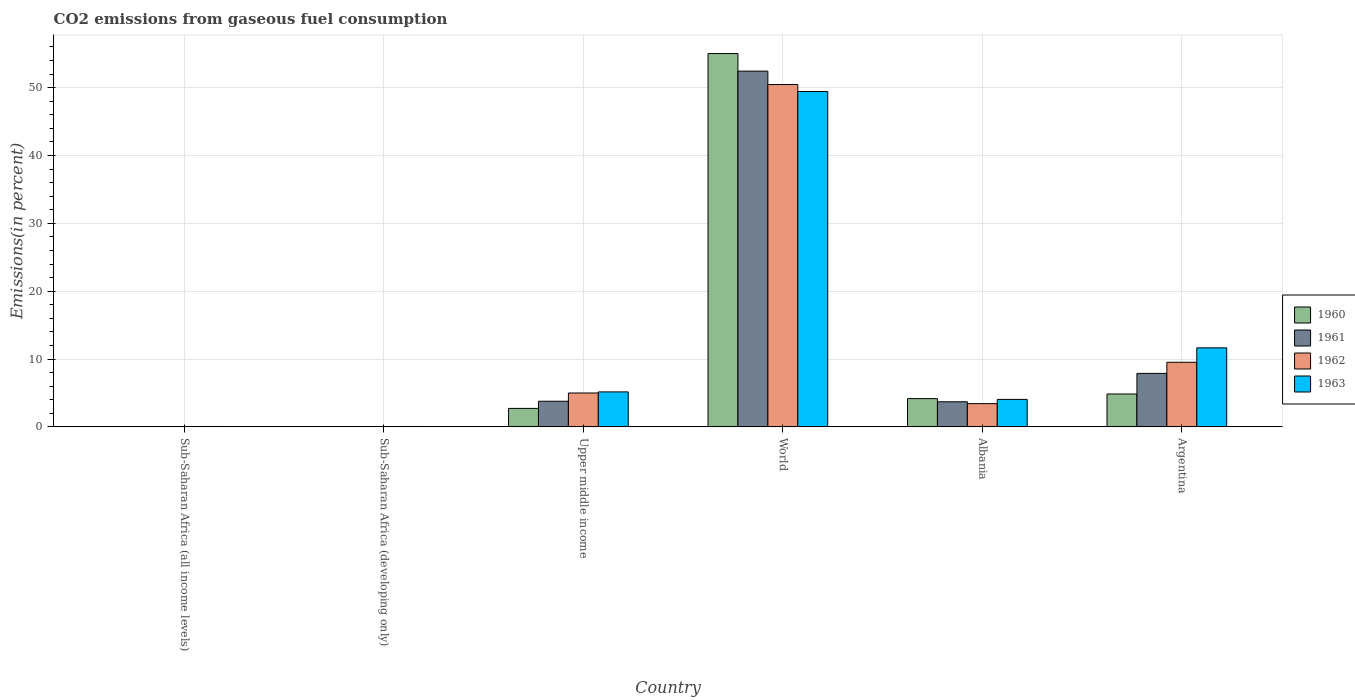How many groups of bars are there?
Offer a very short reply. 6. How many bars are there on the 2nd tick from the left?
Your response must be concise. 4. How many bars are there on the 3rd tick from the right?
Give a very brief answer. 4. What is the label of the 6th group of bars from the left?
Offer a very short reply. Argentina. What is the total CO2 emitted in 1961 in World?
Your response must be concise. 52.43. Across all countries, what is the maximum total CO2 emitted in 1963?
Offer a very short reply. 49.43. Across all countries, what is the minimum total CO2 emitted in 1962?
Make the answer very short. 0.01. In which country was the total CO2 emitted in 1962 minimum?
Keep it short and to the point. Sub-Saharan Africa (all income levels). What is the total total CO2 emitted in 1961 in the graph?
Your answer should be compact. 67.81. What is the difference between the total CO2 emitted in 1962 in Albania and that in Sub-Saharan Africa (all income levels)?
Provide a succinct answer. 3.41. What is the difference between the total CO2 emitted in 1963 in Albania and the total CO2 emitted in 1961 in World?
Provide a succinct answer. -48.38. What is the average total CO2 emitted in 1962 per country?
Give a very brief answer. 11.4. What is the difference between the total CO2 emitted of/in 1962 and total CO2 emitted of/in 1961 in World?
Your answer should be very brief. -1.98. What is the ratio of the total CO2 emitted in 1962 in Argentina to that in World?
Your answer should be compact. 0.19. Is the total CO2 emitted in 1960 in Albania less than that in Upper middle income?
Your answer should be very brief. No. What is the difference between the highest and the second highest total CO2 emitted in 1962?
Offer a very short reply. -40.94. What is the difference between the highest and the lowest total CO2 emitted in 1962?
Your response must be concise. 50.44. In how many countries, is the total CO2 emitted in 1960 greater than the average total CO2 emitted in 1960 taken over all countries?
Your answer should be compact. 1. Is the sum of the total CO2 emitted in 1961 in Sub-Saharan Africa (developing only) and World greater than the maximum total CO2 emitted in 1962 across all countries?
Keep it short and to the point. Yes. What does the 2nd bar from the left in Upper middle income represents?
Offer a terse response. 1961. Are all the bars in the graph horizontal?
Offer a very short reply. No. What is the difference between two consecutive major ticks on the Y-axis?
Ensure brevity in your answer.  10. Where does the legend appear in the graph?
Make the answer very short. Center right. How are the legend labels stacked?
Provide a succinct answer. Vertical. What is the title of the graph?
Your answer should be very brief. CO2 emissions from gaseous fuel consumption. Does "2006" appear as one of the legend labels in the graph?
Keep it short and to the point. No. What is the label or title of the Y-axis?
Give a very brief answer. Emissions(in percent). What is the Emissions(in percent) in 1960 in Sub-Saharan Africa (all income levels)?
Give a very brief answer. 0.01. What is the Emissions(in percent) in 1961 in Sub-Saharan Africa (all income levels)?
Provide a succinct answer. 0.01. What is the Emissions(in percent) of 1962 in Sub-Saharan Africa (all income levels)?
Your answer should be very brief. 0.01. What is the Emissions(in percent) of 1963 in Sub-Saharan Africa (all income levels)?
Your response must be concise. 0.06. What is the Emissions(in percent) in 1960 in Sub-Saharan Africa (developing only)?
Your answer should be compact. 0.01. What is the Emissions(in percent) of 1961 in Sub-Saharan Africa (developing only)?
Provide a succinct answer. 0.01. What is the Emissions(in percent) in 1962 in Sub-Saharan Africa (developing only)?
Provide a short and direct response. 0.01. What is the Emissions(in percent) in 1963 in Sub-Saharan Africa (developing only)?
Your answer should be compact. 0.06. What is the Emissions(in percent) of 1960 in Upper middle income?
Provide a short and direct response. 2.72. What is the Emissions(in percent) in 1961 in Upper middle income?
Your answer should be very brief. 3.78. What is the Emissions(in percent) in 1962 in Upper middle income?
Ensure brevity in your answer.  4.99. What is the Emissions(in percent) in 1963 in Upper middle income?
Your response must be concise. 5.15. What is the Emissions(in percent) of 1960 in World?
Your response must be concise. 55.02. What is the Emissions(in percent) of 1961 in World?
Make the answer very short. 52.43. What is the Emissions(in percent) in 1962 in World?
Offer a terse response. 50.46. What is the Emissions(in percent) in 1963 in World?
Make the answer very short. 49.43. What is the Emissions(in percent) of 1960 in Albania?
Provide a short and direct response. 4.17. What is the Emissions(in percent) of 1961 in Albania?
Make the answer very short. 3.7. What is the Emissions(in percent) of 1962 in Albania?
Ensure brevity in your answer.  3.42. What is the Emissions(in percent) of 1963 in Albania?
Make the answer very short. 4.05. What is the Emissions(in percent) of 1960 in Argentina?
Offer a very short reply. 4.85. What is the Emissions(in percent) of 1961 in Argentina?
Give a very brief answer. 7.88. What is the Emissions(in percent) in 1962 in Argentina?
Give a very brief answer. 9.52. What is the Emissions(in percent) of 1963 in Argentina?
Your answer should be compact. 11.65. Across all countries, what is the maximum Emissions(in percent) of 1960?
Your response must be concise. 55.02. Across all countries, what is the maximum Emissions(in percent) of 1961?
Your answer should be very brief. 52.43. Across all countries, what is the maximum Emissions(in percent) of 1962?
Offer a very short reply. 50.46. Across all countries, what is the maximum Emissions(in percent) in 1963?
Provide a succinct answer. 49.43. Across all countries, what is the minimum Emissions(in percent) of 1960?
Keep it short and to the point. 0.01. Across all countries, what is the minimum Emissions(in percent) of 1961?
Provide a succinct answer. 0.01. Across all countries, what is the minimum Emissions(in percent) in 1962?
Your response must be concise. 0.01. Across all countries, what is the minimum Emissions(in percent) of 1963?
Offer a terse response. 0.06. What is the total Emissions(in percent) of 1960 in the graph?
Provide a short and direct response. 66.78. What is the total Emissions(in percent) in 1961 in the graph?
Your answer should be very brief. 67.81. What is the total Emissions(in percent) of 1962 in the graph?
Your response must be concise. 68.42. What is the total Emissions(in percent) in 1963 in the graph?
Provide a short and direct response. 70.4. What is the difference between the Emissions(in percent) of 1960 in Sub-Saharan Africa (all income levels) and that in Sub-Saharan Africa (developing only)?
Provide a succinct answer. -0. What is the difference between the Emissions(in percent) of 1962 in Sub-Saharan Africa (all income levels) and that in Sub-Saharan Africa (developing only)?
Ensure brevity in your answer.  -0. What is the difference between the Emissions(in percent) in 1963 in Sub-Saharan Africa (all income levels) and that in Sub-Saharan Africa (developing only)?
Keep it short and to the point. -0. What is the difference between the Emissions(in percent) of 1960 in Sub-Saharan Africa (all income levels) and that in Upper middle income?
Keep it short and to the point. -2.71. What is the difference between the Emissions(in percent) of 1961 in Sub-Saharan Africa (all income levels) and that in Upper middle income?
Your answer should be compact. -3.77. What is the difference between the Emissions(in percent) in 1962 in Sub-Saharan Africa (all income levels) and that in Upper middle income?
Provide a short and direct response. -4.98. What is the difference between the Emissions(in percent) of 1963 in Sub-Saharan Africa (all income levels) and that in Upper middle income?
Keep it short and to the point. -5.1. What is the difference between the Emissions(in percent) in 1960 in Sub-Saharan Africa (all income levels) and that in World?
Give a very brief answer. -55.01. What is the difference between the Emissions(in percent) of 1961 in Sub-Saharan Africa (all income levels) and that in World?
Make the answer very short. -52.42. What is the difference between the Emissions(in percent) in 1962 in Sub-Saharan Africa (all income levels) and that in World?
Offer a terse response. -50.44. What is the difference between the Emissions(in percent) of 1963 in Sub-Saharan Africa (all income levels) and that in World?
Keep it short and to the point. -49.38. What is the difference between the Emissions(in percent) of 1960 in Sub-Saharan Africa (all income levels) and that in Albania?
Your response must be concise. -4.15. What is the difference between the Emissions(in percent) in 1961 in Sub-Saharan Africa (all income levels) and that in Albania?
Provide a short and direct response. -3.69. What is the difference between the Emissions(in percent) of 1962 in Sub-Saharan Africa (all income levels) and that in Albania?
Offer a very short reply. -3.41. What is the difference between the Emissions(in percent) of 1963 in Sub-Saharan Africa (all income levels) and that in Albania?
Make the answer very short. -3.99. What is the difference between the Emissions(in percent) in 1960 in Sub-Saharan Africa (all income levels) and that in Argentina?
Offer a very short reply. -4.83. What is the difference between the Emissions(in percent) of 1961 in Sub-Saharan Africa (all income levels) and that in Argentina?
Provide a short and direct response. -7.87. What is the difference between the Emissions(in percent) in 1962 in Sub-Saharan Africa (all income levels) and that in Argentina?
Your answer should be very brief. -9.51. What is the difference between the Emissions(in percent) of 1963 in Sub-Saharan Africa (all income levels) and that in Argentina?
Provide a short and direct response. -11.59. What is the difference between the Emissions(in percent) of 1960 in Sub-Saharan Africa (developing only) and that in Upper middle income?
Give a very brief answer. -2.71. What is the difference between the Emissions(in percent) in 1961 in Sub-Saharan Africa (developing only) and that in Upper middle income?
Your answer should be very brief. -3.77. What is the difference between the Emissions(in percent) in 1962 in Sub-Saharan Africa (developing only) and that in Upper middle income?
Your response must be concise. -4.98. What is the difference between the Emissions(in percent) of 1963 in Sub-Saharan Africa (developing only) and that in Upper middle income?
Your response must be concise. -5.1. What is the difference between the Emissions(in percent) in 1960 in Sub-Saharan Africa (developing only) and that in World?
Give a very brief answer. -55.01. What is the difference between the Emissions(in percent) of 1961 in Sub-Saharan Africa (developing only) and that in World?
Your answer should be very brief. -52.42. What is the difference between the Emissions(in percent) of 1962 in Sub-Saharan Africa (developing only) and that in World?
Your response must be concise. -50.44. What is the difference between the Emissions(in percent) of 1963 in Sub-Saharan Africa (developing only) and that in World?
Offer a very short reply. -49.38. What is the difference between the Emissions(in percent) in 1960 in Sub-Saharan Africa (developing only) and that in Albania?
Give a very brief answer. -4.15. What is the difference between the Emissions(in percent) in 1961 in Sub-Saharan Africa (developing only) and that in Albania?
Offer a terse response. -3.69. What is the difference between the Emissions(in percent) in 1962 in Sub-Saharan Africa (developing only) and that in Albania?
Give a very brief answer. -3.41. What is the difference between the Emissions(in percent) of 1963 in Sub-Saharan Africa (developing only) and that in Albania?
Your response must be concise. -3.99. What is the difference between the Emissions(in percent) in 1960 in Sub-Saharan Africa (developing only) and that in Argentina?
Offer a terse response. -4.83. What is the difference between the Emissions(in percent) in 1961 in Sub-Saharan Africa (developing only) and that in Argentina?
Keep it short and to the point. -7.87. What is the difference between the Emissions(in percent) of 1962 in Sub-Saharan Africa (developing only) and that in Argentina?
Offer a terse response. -9.51. What is the difference between the Emissions(in percent) in 1963 in Sub-Saharan Africa (developing only) and that in Argentina?
Your answer should be very brief. -11.59. What is the difference between the Emissions(in percent) in 1960 in Upper middle income and that in World?
Your answer should be compact. -52.3. What is the difference between the Emissions(in percent) in 1961 in Upper middle income and that in World?
Make the answer very short. -48.66. What is the difference between the Emissions(in percent) in 1962 in Upper middle income and that in World?
Provide a succinct answer. -45.46. What is the difference between the Emissions(in percent) of 1963 in Upper middle income and that in World?
Your answer should be compact. -44.28. What is the difference between the Emissions(in percent) of 1960 in Upper middle income and that in Albania?
Give a very brief answer. -1.44. What is the difference between the Emissions(in percent) in 1961 in Upper middle income and that in Albania?
Provide a succinct answer. 0.08. What is the difference between the Emissions(in percent) in 1962 in Upper middle income and that in Albania?
Provide a short and direct response. 1.57. What is the difference between the Emissions(in percent) in 1963 in Upper middle income and that in Albania?
Your response must be concise. 1.11. What is the difference between the Emissions(in percent) in 1960 in Upper middle income and that in Argentina?
Ensure brevity in your answer.  -2.12. What is the difference between the Emissions(in percent) in 1961 in Upper middle income and that in Argentina?
Give a very brief answer. -4.1. What is the difference between the Emissions(in percent) in 1962 in Upper middle income and that in Argentina?
Your answer should be very brief. -4.53. What is the difference between the Emissions(in percent) of 1963 in Upper middle income and that in Argentina?
Your answer should be very brief. -6.49. What is the difference between the Emissions(in percent) of 1960 in World and that in Albania?
Your answer should be compact. 50.86. What is the difference between the Emissions(in percent) in 1961 in World and that in Albania?
Offer a terse response. 48.74. What is the difference between the Emissions(in percent) of 1962 in World and that in Albania?
Ensure brevity in your answer.  47.03. What is the difference between the Emissions(in percent) in 1963 in World and that in Albania?
Your response must be concise. 45.38. What is the difference between the Emissions(in percent) of 1960 in World and that in Argentina?
Your answer should be very brief. 50.18. What is the difference between the Emissions(in percent) of 1961 in World and that in Argentina?
Keep it short and to the point. 44.55. What is the difference between the Emissions(in percent) of 1962 in World and that in Argentina?
Make the answer very short. 40.94. What is the difference between the Emissions(in percent) of 1963 in World and that in Argentina?
Your answer should be compact. 37.78. What is the difference between the Emissions(in percent) of 1960 in Albania and that in Argentina?
Provide a short and direct response. -0.68. What is the difference between the Emissions(in percent) of 1961 in Albania and that in Argentina?
Make the answer very short. -4.18. What is the difference between the Emissions(in percent) of 1962 in Albania and that in Argentina?
Ensure brevity in your answer.  -6.1. What is the difference between the Emissions(in percent) of 1963 in Albania and that in Argentina?
Your response must be concise. -7.6. What is the difference between the Emissions(in percent) in 1960 in Sub-Saharan Africa (all income levels) and the Emissions(in percent) in 1961 in Sub-Saharan Africa (developing only)?
Ensure brevity in your answer.  0. What is the difference between the Emissions(in percent) of 1960 in Sub-Saharan Africa (all income levels) and the Emissions(in percent) of 1962 in Sub-Saharan Africa (developing only)?
Provide a short and direct response. -0. What is the difference between the Emissions(in percent) of 1960 in Sub-Saharan Africa (all income levels) and the Emissions(in percent) of 1963 in Sub-Saharan Africa (developing only)?
Your answer should be very brief. -0.05. What is the difference between the Emissions(in percent) of 1961 in Sub-Saharan Africa (all income levels) and the Emissions(in percent) of 1962 in Sub-Saharan Africa (developing only)?
Ensure brevity in your answer.  -0. What is the difference between the Emissions(in percent) of 1961 in Sub-Saharan Africa (all income levels) and the Emissions(in percent) of 1963 in Sub-Saharan Africa (developing only)?
Offer a terse response. -0.05. What is the difference between the Emissions(in percent) in 1962 in Sub-Saharan Africa (all income levels) and the Emissions(in percent) in 1963 in Sub-Saharan Africa (developing only)?
Offer a terse response. -0.04. What is the difference between the Emissions(in percent) in 1960 in Sub-Saharan Africa (all income levels) and the Emissions(in percent) in 1961 in Upper middle income?
Offer a terse response. -3.77. What is the difference between the Emissions(in percent) of 1960 in Sub-Saharan Africa (all income levels) and the Emissions(in percent) of 1962 in Upper middle income?
Your response must be concise. -4.98. What is the difference between the Emissions(in percent) in 1960 in Sub-Saharan Africa (all income levels) and the Emissions(in percent) in 1963 in Upper middle income?
Offer a terse response. -5.14. What is the difference between the Emissions(in percent) in 1961 in Sub-Saharan Africa (all income levels) and the Emissions(in percent) in 1962 in Upper middle income?
Ensure brevity in your answer.  -4.98. What is the difference between the Emissions(in percent) in 1961 in Sub-Saharan Africa (all income levels) and the Emissions(in percent) in 1963 in Upper middle income?
Ensure brevity in your answer.  -5.14. What is the difference between the Emissions(in percent) of 1962 in Sub-Saharan Africa (all income levels) and the Emissions(in percent) of 1963 in Upper middle income?
Your answer should be very brief. -5.14. What is the difference between the Emissions(in percent) of 1960 in Sub-Saharan Africa (all income levels) and the Emissions(in percent) of 1961 in World?
Your answer should be very brief. -52.42. What is the difference between the Emissions(in percent) in 1960 in Sub-Saharan Africa (all income levels) and the Emissions(in percent) in 1962 in World?
Offer a very short reply. -50.44. What is the difference between the Emissions(in percent) of 1960 in Sub-Saharan Africa (all income levels) and the Emissions(in percent) of 1963 in World?
Offer a terse response. -49.42. What is the difference between the Emissions(in percent) in 1961 in Sub-Saharan Africa (all income levels) and the Emissions(in percent) in 1962 in World?
Give a very brief answer. -50.44. What is the difference between the Emissions(in percent) in 1961 in Sub-Saharan Africa (all income levels) and the Emissions(in percent) in 1963 in World?
Make the answer very short. -49.42. What is the difference between the Emissions(in percent) of 1962 in Sub-Saharan Africa (all income levels) and the Emissions(in percent) of 1963 in World?
Keep it short and to the point. -49.42. What is the difference between the Emissions(in percent) of 1960 in Sub-Saharan Africa (all income levels) and the Emissions(in percent) of 1961 in Albania?
Your answer should be very brief. -3.69. What is the difference between the Emissions(in percent) in 1960 in Sub-Saharan Africa (all income levels) and the Emissions(in percent) in 1962 in Albania?
Keep it short and to the point. -3.41. What is the difference between the Emissions(in percent) of 1960 in Sub-Saharan Africa (all income levels) and the Emissions(in percent) of 1963 in Albania?
Provide a short and direct response. -4.04. What is the difference between the Emissions(in percent) in 1961 in Sub-Saharan Africa (all income levels) and the Emissions(in percent) in 1962 in Albania?
Ensure brevity in your answer.  -3.41. What is the difference between the Emissions(in percent) in 1961 in Sub-Saharan Africa (all income levels) and the Emissions(in percent) in 1963 in Albania?
Give a very brief answer. -4.04. What is the difference between the Emissions(in percent) in 1962 in Sub-Saharan Africa (all income levels) and the Emissions(in percent) in 1963 in Albania?
Ensure brevity in your answer.  -4.03. What is the difference between the Emissions(in percent) of 1960 in Sub-Saharan Africa (all income levels) and the Emissions(in percent) of 1961 in Argentina?
Your answer should be very brief. -7.87. What is the difference between the Emissions(in percent) in 1960 in Sub-Saharan Africa (all income levels) and the Emissions(in percent) in 1962 in Argentina?
Your answer should be very brief. -9.51. What is the difference between the Emissions(in percent) of 1960 in Sub-Saharan Africa (all income levels) and the Emissions(in percent) of 1963 in Argentina?
Ensure brevity in your answer.  -11.64. What is the difference between the Emissions(in percent) in 1961 in Sub-Saharan Africa (all income levels) and the Emissions(in percent) in 1962 in Argentina?
Make the answer very short. -9.51. What is the difference between the Emissions(in percent) in 1961 in Sub-Saharan Africa (all income levels) and the Emissions(in percent) in 1963 in Argentina?
Provide a succinct answer. -11.64. What is the difference between the Emissions(in percent) in 1962 in Sub-Saharan Africa (all income levels) and the Emissions(in percent) in 1963 in Argentina?
Your answer should be compact. -11.63. What is the difference between the Emissions(in percent) of 1960 in Sub-Saharan Africa (developing only) and the Emissions(in percent) of 1961 in Upper middle income?
Give a very brief answer. -3.77. What is the difference between the Emissions(in percent) in 1960 in Sub-Saharan Africa (developing only) and the Emissions(in percent) in 1962 in Upper middle income?
Your response must be concise. -4.98. What is the difference between the Emissions(in percent) of 1960 in Sub-Saharan Africa (developing only) and the Emissions(in percent) of 1963 in Upper middle income?
Give a very brief answer. -5.14. What is the difference between the Emissions(in percent) in 1961 in Sub-Saharan Africa (developing only) and the Emissions(in percent) in 1962 in Upper middle income?
Your response must be concise. -4.98. What is the difference between the Emissions(in percent) in 1961 in Sub-Saharan Africa (developing only) and the Emissions(in percent) in 1963 in Upper middle income?
Your answer should be compact. -5.14. What is the difference between the Emissions(in percent) in 1962 in Sub-Saharan Africa (developing only) and the Emissions(in percent) in 1963 in Upper middle income?
Keep it short and to the point. -5.14. What is the difference between the Emissions(in percent) in 1960 in Sub-Saharan Africa (developing only) and the Emissions(in percent) in 1961 in World?
Ensure brevity in your answer.  -52.42. What is the difference between the Emissions(in percent) in 1960 in Sub-Saharan Africa (developing only) and the Emissions(in percent) in 1962 in World?
Offer a very short reply. -50.44. What is the difference between the Emissions(in percent) of 1960 in Sub-Saharan Africa (developing only) and the Emissions(in percent) of 1963 in World?
Make the answer very short. -49.42. What is the difference between the Emissions(in percent) in 1961 in Sub-Saharan Africa (developing only) and the Emissions(in percent) in 1962 in World?
Offer a terse response. -50.44. What is the difference between the Emissions(in percent) in 1961 in Sub-Saharan Africa (developing only) and the Emissions(in percent) in 1963 in World?
Your response must be concise. -49.42. What is the difference between the Emissions(in percent) of 1962 in Sub-Saharan Africa (developing only) and the Emissions(in percent) of 1963 in World?
Ensure brevity in your answer.  -49.42. What is the difference between the Emissions(in percent) in 1960 in Sub-Saharan Africa (developing only) and the Emissions(in percent) in 1961 in Albania?
Provide a short and direct response. -3.69. What is the difference between the Emissions(in percent) in 1960 in Sub-Saharan Africa (developing only) and the Emissions(in percent) in 1962 in Albania?
Give a very brief answer. -3.41. What is the difference between the Emissions(in percent) in 1960 in Sub-Saharan Africa (developing only) and the Emissions(in percent) in 1963 in Albania?
Ensure brevity in your answer.  -4.04. What is the difference between the Emissions(in percent) in 1961 in Sub-Saharan Africa (developing only) and the Emissions(in percent) in 1962 in Albania?
Offer a very short reply. -3.41. What is the difference between the Emissions(in percent) in 1961 in Sub-Saharan Africa (developing only) and the Emissions(in percent) in 1963 in Albania?
Provide a short and direct response. -4.04. What is the difference between the Emissions(in percent) in 1962 in Sub-Saharan Africa (developing only) and the Emissions(in percent) in 1963 in Albania?
Your answer should be compact. -4.03. What is the difference between the Emissions(in percent) of 1960 in Sub-Saharan Africa (developing only) and the Emissions(in percent) of 1961 in Argentina?
Keep it short and to the point. -7.87. What is the difference between the Emissions(in percent) of 1960 in Sub-Saharan Africa (developing only) and the Emissions(in percent) of 1962 in Argentina?
Make the answer very short. -9.51. What is the difference between the Emissions(in percent) of 1960 in Sub-Saharan Africa (developing only) and the Emissions(in percent) of 1963 in Argentina?
Provide a short and direct response. -11.64. What is the difference between the Emissions(in percent) of 1961 in Sub-Saharan Africa (developing only) and the Emissions(in percent) of 1962 in Argentina?
Make the answer very short. -9.51. What is the difference between the Emissions(in percent) in 1961 in Sub-Saharan Africa (developing only) and the Emissions(in percent) in 1963 in Argentina?
Provide a succinct answer. -11.64. What is the difference between the Emissions(in percent) of 1962 in Sub-Saharan Africa (developing only) and the Emissions(in percent) of 1963 in Argentina?
Your response must be concise. -11.63. What is the difference between the Emissions(in percent) of 1960 in Upper middle income and the Emissions(in percent) of 1961 in World?
Make the answer very short. -49.71. What is the difference between the Emissions(in percent) of 1960 in Upper middle income and the Emissions(in percent) of 1962 in World?
Offer a very short reply. -47.73. What is the difference between the Emissions(in percent) in 1960 in Upper middle income and the Emissions(in percent) in 1963 in World?
Your answer should be very brief. -46.71. What is the difference between the Emissions(in percent) of 1961 in Upper middle income and the Emissions(in percent) of 1962 in World?
Ensure brevity in your answer.  -46.68. What is the difference between the Emissions(in percent) of 1961 in Upper middle income and the Emissions(in percent) of 1963 in World?
Ensure brevity in your answer.  -45.66. What is the difference between the Emissions(in percent) of 1962 in Upper middle income and the Emissions(in percent) of 1963 in World?
Ensure brevity in your answer.  -44.44. What is the difference between the Emissions(in percent) in 1960 in Upper middle income and the Emissions(in percent) in 1961 in Albania?
Provide a succinct answer. -0.98. What is the difference between the Emissions(in percent) of 1960 in Upper middle income and the Emissions(in percent) of 1962 in Albania?
Give a very brief answer. -0.7. What is the difference between the Emissions(in percent) in 1960 in Upper middle income and the Emissions(in percent) in 1963 in Albania?
Offer a terse response. -1.33. What is the difference between the Emissions(in percent) of 1961 in Upper middle income and the Emissions(in percent) of 1962 in Albania?
Keep it short and to the point. 0.35. What is the difference between the Emissions(in percent) of 1961 in Upper middle income and the Emissions(in percent) of 1963 in Albania?
Offer a very short reply. -0.27. What is the difference between the Emissions(in percent) of 1962 in Upper middle income and the Emissions(in percent) of 1963 in Albania?
Make the answer very short. 0.94. What is the difference between the Emissions(in percent) of 1960 in Upper middle income and the Emissions(in percent) of 1961 in Argentina?
Your answer should be compact. -5.16. What is the difference between the Emissions(in percent) of 1960 in Upper middle income and the Emissions(in percent) of 1962 in Argentina?
Keep it short and to the point. -6.8. What is the difference between the Emissions(in percent) in 1960 in Upper middle income and the Emissions(in percent) in 1963 in Argentina?
Ensure brevity in your answer.  -8.93. What is the difference between the Emissions(in percent) in 1961 in Upper middle income and the Emissions(in percent) in 1962 in Argentina?
Provide a short and direct response. -5.74. What is the difference between the Emissions(in percent) in 1961 in Upper middle income and the Emissions(in percent) in 1963 in Argentina?
Your response must be concise. -7.87. What is the difference between the Emissions(in percent) of 1962 in Upper middle income and the Emissions(in percent) of 1963 in Argentina?
Your answer should be compact. -6.66. What is the difference between the Emissions(in percent) in 1960 in World and the Emissions(in percent) in 1961 in Albania?
Give a very brief answer. 51.33. What is the difference between the Emissions(in percent) of 1960 in World and the Emissions(in percent) of 1962 in Albania?
Your answer should be compact. 51.6. What is the difference between the Emissions(in percent) in 1960 in World and the Emissions(in percent) in 1963 in Albania?
Give a very brief answer. 50.98. What is the difference between the Emissions(in percent) of 1961 in World and the Emissions(in percent) of 1962 in Albania?
Keep it short and to the point. 49.01. What is the difference between the Emissions(in percent) in 1961 in World and the Emissions(in percent) in 1963 in Albania?
Give a very brief answer. 48.38. What is the difference between the Emissions(in percent) of 1962 in World and the Emissions(in percent) of 1963 in Albania?
Give a very brief answer. 46.41. What is the difference between the Emissions(in percent) in 1960 in World and the Emissions(in percent) in 1961 in Argentina?
Ensure brevity in your answer.  47.14. What is the difference between the Emissions(in percent) of 1960 in World and the Emissions(in percent) of 1962 in Argentina?
Provide a succinct answer. 45.5. What is the difference between the Emissions(in percent) of 1960 in World and the Emissions(in percent) of 1963 in Argentina?
Provide a succinct answer. 43.38. What is the difference between the Emissions(in percent) of 1961 in World and the Emissions(in percent) of 1962 in Argentina?
Your response must be concise. 42.91. What is the difference between the Emissions(in percent) in 1961 in World and the Emissions(in percent) in 1963 in Argentina?
Make the answer very short. 40.78. What is the difference between the Emissions(in percent) in 1962 in World and the Emissions(in percent) in 1963 in Argentina?
Your response must be concise. 38.81. What is the difference between the Emissions(in percent) of 1960 in Albania and the Emissions(in percent) of 1961 in Argentina?
Offer a terse response. -3.71. What is the difference between the Emissions(in percent) in 1960 in Albania and the Emissions(in percent) in 1962 in Argentina?
Make the answer very short. -5.35. What is the difference between the Emissions(in percent) in 1960 in Albania and the Emissions(in percent) in 1963 in Argentina?
Your answer should be very brief. -7.48. What is the difference between the Emissions(in percent) of 1961 in Albania and the Emissions(in percent) of 1962 in Argentina?
Offer a very short reply. -5.82. What is the difference between the Emissions(in percent) of 1961 in Albania and the Emissions(in percent) of 1963 in Argentina?
Your answer should be compact. -7.95. What is the difference between the Emissions(in percent) in 1962 in Albania and the Emissions(in percent) in 1963 in Argentina?
Your answer should be compact. -8.23. What is the average Emissions(in percent) in 1960 per country?
Your answer should be compact. 11.13. What is the average Emissions(in percent) in 1961 per country?
Provide a succinct answer. 11.3. What is the average Emissions(in percent) of 1962 per country?
Your answer should be compact. 11.4. What is the average Emissions(in percent) of 1963 per country?
Offer a terse response. 11.73. What is the difference between the Emissions(in percent) in 1960 and Emissions(in percent) in 1962 in Sub-Saharan Africa (all income levels)?
Offer a terse response. -0. What is the difference between the Emissions(in percent) in 1960 and Emissions(in percent) in 1963 in Sub-Saharan Africa (all income levels)?
Your answer should be compact. -0.05. What is the difference between the Emissions(in percent) in 1961 and Emissions(in percent) in 1962 in Sub-Saharan Africa (all income levels)?
Your response must be concise. -0. What is the difference between the Emissions(in percent) in 1961 and Emissions(in percent) in 1963 in Sub-Saharan Africa (all income levels)?
Your answer should be very brief. -0.05. What is the difference between the Emissions(in percent) in 1962 and Emissions(in percent) in 1963 in Sub-Saharan Africa (all income levels)?
Offer a very short reply. -0.04. What is the difference between the Emissions(in percent) in 1960 and Emissions(in percent) in 1962 in Sub-Saharan Africa (developing only)?
Ensure brevity in your answer.  -0. What is the difference between the Emissions(in percent) in 1960 and Emissions(in percent) in 1963 in Sub-Saharan Africa (developing only)?
Provide a succinct answer. -0.05. What is the difference between the Emissions(in percent) in 1961 and Emissions(in percent) in 1962 in Sub-Saharan Africa (developing only)?
Your response must be concise. -0. What is the difference between the Emissions(in percent) of 1961 and Emissions(in percent) of 1963 in Sub-Saharan Africa (developing only)?
Provide a succinct answer. -0.05. What is the difference between the Emissions(in percent) of 1962 and Emissions(in percent) of 1963 in Sub-Saharan Africa (developing only)?
Provide a short and direct response. -0.04. What is the difference between the Emissions(in percent) in 1960 and Emissions(in percent) in 1961 in Upper middle income?
Provide a short and direct response. -1.06. What is the difference between the Emissions(in percent) of 1960 and Emissions(in percent) of 1962 in Upper middle income?
Provide a succinct answer. -2.27. What is the difference between the Emissions(in percent) of 1960 and Emissions(in percent) of 1963 in Upper middle income?
Offer a terse response. -2.43. What is the difference between the Emissions(in percent) of 1961 and Emissions(in percent) of 1962 in Upper middle income?
Your answer should be compact. -1.22. What is the difference between the Emissions(in percent) in 1961 and Emissions(in percent) in 1963 in Upper middle income?
Offer a very short reply. -1.38. What is the difference between the Emissions(in percent) of 1962 and Emissions(in percent) of 1963 in Upper middle income?
Offer a terse response. -0.16. What is the difference between the Emissions(in percent) in 1960 and Emissions(in percent) in 1961 in World?
Keep it short and to the point. 2.59. What is the difference between the Emissions(in percent) of 1960 and Emissions(in percent) of 1962 in World?
Ensure brevity in your answer.  4.57. What is the difference between the Emissions(in percent) of 1960 and Emissions(in percent) of 1963 in World?
Your answer should be very brief. 5.59. What is the difference between the Emissions(in percent) in 1961 and Emissions(in percent) in 1962 in World?
Your answer should be very brief. 1.98. What is the difference between the Emissions(in percent) in 1961 and Emissions(in percent) in 1963 in World?
Your response must be concise. 3. What is the difference between the Emissions(in percent) of 1962 and Emissions(in percent) of 1963 in World?
Provide a succinct answer. 1.02. What is the difference between the Emissions(in percent) of 1960 and Emissions(in percent) of 1961 in Albania?
Your answer should be very brief. 0.47. What is the difference between the Emissions(in percent) of 1960 and Emissions(in percent) of 1962 in Albania?
Offer a terse response. 0.74. What is the difference between the Emissions(in percent) in 1960 and Emissions(in percent) in 1963 in Albania?
Make the answer very short. 0.12. What is the difference between the Emissions(in percent) of 1961 and Emissions(in percent) of 1962 in Albania?
Your answer should be compact. 0.28. What is the difference between the Emissions(in percent) in 1961 and Emissions(in percent) in 1963 in Albania?
Provide a succinct answer. -0.35. What is the difference between the Emissions(in percent) of 1962 and Emissions(in percent) of 1963 in Albania?
Your answer should be compact. -0.63. What is the difference between the Emissions(in percent) of 1960 and Emissions(in percent) of 1961 in Argentina?
Your response must be concise. -3.04. What is the difference between the Emissions(in percent) of 1960 and Emissions(in percent) of 1962 in Argentina?
Your answer should be very brief. -4.67. What is the difference between the Emissions(in percent) of 1960 and Emissions(in percent) of 1963 in Argentina?
Give a very brief answer. -6.8. What is the difference between the Emissions(in percent) of 1961 and Emissions(in percent) of 1962 in Argentina?
Provide a short and direct response. -1.64. What is the difference between the Emissions(in percent) in 1961 and Emissions(in percent) in 1963 in Argentina?
Offer a terse response. -3.77. What is the difference between the Emissions(in percent) in 1962 and Emissions(in percent) in 1963 in Argentina?
Keep it short and to the point. -2.13. What is the ratio of the Emissions(in percent) of 1960 in Sub-Saharan Africa (all income levels) to that in Sub-Saharan Africa (developing only)?
Provide a short and direct response. 1. What is the ratio of the Emissions(in percent) in 1961 in Sub-Saharan Africa (all income levels) to that in Sub-Saharan Africa (developing only)?
Provide a short and direct response. 1. What is the ratio of the Emissions(in percent) of 1962 in Sub-Saharan Africa (all income levels) to that in Sub-Saharan Africa (developing only)?
Offer a very short reply. 1. What is the ratio of the Emissions(in percent) of 1963 in Sub-Saharan Africa (all income levels) to that in Sub-Saharan Africa (developing only)?
Provide a succinct answer. 1. What is the ratio of the Emissions(in percent) of 1960 in Sub-Saharan Africa (all income levels) to that in Upper middle income?
Give a very brief answer. 0. What is the ratio of the Emissions(in percent) in 1961 in Sub-Saharan Africa (all income levels) to that in Upper middle income?
Provide a succinct answer. 0. What is the ratio of the Emissions(in percent) of 1962 in Sub-Saharan Africa (all income levels) to that in Upper middle income?
Your answer should be compact. 0. What is the ratio of the Emissions(in percent) of 1963 in Sub-Saharan Africa (all income levels) to that in Upper middle income?
Ensure brevity in your answer.  0.01. What is the ratio of the Emissions(in percent) of 1960 in Sub-Saharan Africa (all income levels) to that in World?
Offer a very short reply. 0. What is the ratio of the Emissions(in percent) in 1962 in Sub-Saharan Africa (all income levels) to that in World?
Offer a terse response. 0. What is the ratio of the Emissions(in percent) of 1963 in Sub-Saharan Africa (all income levels) to that in World?
Keep it short and to the point. 0. What is the ratio of the Emissions(in percent) of 1960 in Sub-Saharan Africa (all income levels) to that in Albania?
Offer a terse response. 0. What is the ratio of the Emissions(in percent) of 1961 in Sub-Saharan Africa (all income levels) to that in Albania?
Offer a terse response. 0. What is the ratio of the Emissions(in percent) in 1962 in Sub-Saharan Africa (all income levels) to that in Albania?
Offer a very short reply. 0. What is the ratio of the Emissions(in percent) of 1963 in Sub-Saharan Africa (all income levels) to that in Albania?
Keep it short and to the point. 0.01. What is the ratio of the Emissions(in percent) in 1960 in Sub-Saharan Africa (all income levels) to that in Argentina?
Give a very brief answer. 0. What is the ratio of the Emissions(in percent) of 1961 in Sub-Saharan Africa (all income levels) to that in Argentina?
Ensure brevity in your answer.  0. What is the ratio of the Emissions(in percent) in 1962 in Sub-Saharan Africa (all income levels) to that in Argentina?
Make the answer very short. 0. What is the ratio of the Emissions(in percent) in 1963 in Sub-Saharan Africa (all income levels) to that in Argentina?
Give a very brief answer. 0. What is the ratio of the Emissions(in percent) in 1960 in Sub-Saharan Africa (developing only) to that in Upper middle income?
Your answer should be compact. 0. What is the ratio of the Emissions(in percent) in 1961 in Sub-Saharan Africa (developing only) to that in Upper middle income?
Give a very brief answer. 0. What is the ratio of the Emissions(in percent) in 1962 in Sub-Saharan Africa (developing only) to that in Upper middle income?
Offer a very short reply. 0. What is the ratio of the Emissions(in percent) in 1963 in Sub-Saharan Africa (developing only) to that in Upper middle income?
Your answer should be compact. 0.01. What is the ratio of the Emissions(in percent) of 1960 in Sub-Saharan Africa (developing only) to that in World?
Your answer should be very brief. 0. What is the ratio of the Emissions(in percent) of 1961 in Sub-Saharan Africa (developing only) to that in World?
Make the answer very short. 0. What is the ratio of the Emissions(in percent) of 1963 in Sub-Saharan Africa (developing only) to that in World?
Offer a very short reply. 0. What is the ratio of the Emissions(in percent) of 1960 in Sub-Saharan Africa (developing only) to that in Albania?
Keep it short and to the point. 0. What is the ratio of the Emissions(in percent) in 1961 in Sub-Saharan Africa (developing only) to that in Albania?
Offer a terse response. 0. What is the ratio of the Emissions(in percent) of 1962 in Sub-Saharan Africa (developing only) to that in Albania?
Offer a terse response. 0. What is the ratio of the Emissions(in percent) in 1963 in Sub-Saharan Africa (developing only) to that in Albania?
Ensure brevity in your answer.  0.01. What is the ratio of the Emissions(in percent) of 1960 in Sub-Saharan Africa (developing only) to that in Argentina?
Your response must be concise. 0. What is the ratio of the Emissions(in percent) of 1961 in Sub-Saharan Africa (developing only) to that in Argentina?
Give a very brief answer. 0. What is the ratio of the Emissions(in percent) of 1962 in Sub-Saharan Africa (developing only) to that in Argentina?
Your answer should be compact. 0. What is the ratio of the Emissions(in percent) in 1963 in Sub-Saharan Africa (developing only) to that in Argentina?
Keep it short and to the point. 0. What is the ratio of the Emissions(in percent) in 1960 in Upper middle income to that in World?
Ensure brevity in your answer.  0.05. What is the ratio of the Emissions(in percent) in 1961 in Upper middle income to that in World?
Your answer should be compact. 0.07. What is the ratio of the Emissions(in percent) in 1962 in Upper middle income to that in World?
Keep it short and to the point. 0.1. What is the ratio of the Emissions(in percent) in 1963 in Upper middle income to that in World?
Ensure brevity in your answer.  0.1. What is the ratio of the Emissions(in percent) in 1960 in Upper middle income to that in Albania?
Offer a terse response. 0.65. What is the ratio of the Emissions(in percent) in 1961 in Upper middle income to that in Albania?
Make the answer very short. 1.02. What is the ratio of the Emissions(in percent) in 1962 in Upper middle income to that in Albania?
Your response must be concise. 1.46. What is the ratio of the Emissions(in percent) in 1963 in Upper middle income to that in Albania?
Make the answer very short. 1.27. What is the ratio of the Emissions(in percent) of 1960 in Upper middle income to that in Argentina?
Provide a short and direct response. 0.56. What is the ratio of the Emissions(in percent) in 1961 in Upper middle income to that in Argentina?
Offer a terse response. 0.48. What is the ratio of the Emissions(in percent) of 1962 in Upper middle income to that in Argentina?
Your answer should be very brief. 0.52. What is the ratio of the Emissions(in percent) in 1963 in Upper middle income to that in Argentina?
Provide a short and direct response. 0.44. What is the ratio of the Emissions(in percent) in 1960 in World to that in Albania?
Keep it short and to the point. 13.21. What is the ratio of the Emissions(in percent) in 1961 in World to that in Albania?
Make the answer very short. 14.18. What is the ratio of the Emissions(in percent) of 1962 in World to that in Albania?
Offer a very short reply. 14.74. What is the ratio of the Emissions(in percent) of 1963 in World to that in Albania?
Your answer should be compact. 12.21. What is the ratio of the Emissions(in percent) of 1960 in World to that in Argentina?
Make the answer very short. 11.36. What is the ratio of the Emissions(in percent) of 1961 in World to that in Argentina?
Make the answer very short. 6.65. What is the ratio of the Emissions(in percent) in 1962 in World to that in Argentina?
Offer a terse response. 5.3. What is the ratio of the Emissions(in percent) in 1963 in World to that in Argentina?
Your answer should be compact. 4.24. What is the ratio of the Emissions(in percent) of 1960 in Albania to that in Argentina?
Your answer should be very brief. 0.86. What is the ratio of the Emissions(in percent) of 1961 in Albania to that in Argentina?
Offer a very short reply. 0.47. What is the ratio of the Emissions(in percent) of 1962 in Albania to that in Argentina?
Offer a terse response. 0.36. What is the ratio of the Emissions(in percent) in 1963 in Albania to that in Argentina?
Give a very brief answer. 0.35. What is the difference between the highest and the second highest Emissions(in percent) of 1960?
Your answer should be very brief. 50.18. What is the difference between the highest and the second highest Emissions(in percent) of 1961?
Offer a terse response. 44.55. What is the difference between the highest and the second highest Emissions(in percent) in 1962?
Make the answer very short. 40.94. What is the difference between the highest and the second highest Emissions(in percent) in 1963?
Offer a very short reply. 37.78. What is the difference between the highest and the lowest Emissions(in percent) of 1960?
Offer a terse response. 55.01. What is the difference between the highest and the lowest Emissions(in percent) in 1961?
Offer a very short reply. 52.42. What is the difference between the highest and the lowest Emissions(in percent) of 1962?
Offer a terse response. 50.44. What is the difference between the highest and the lowest Emissions(in percent) of 1963?
Offer a very short reply. 49.38. 